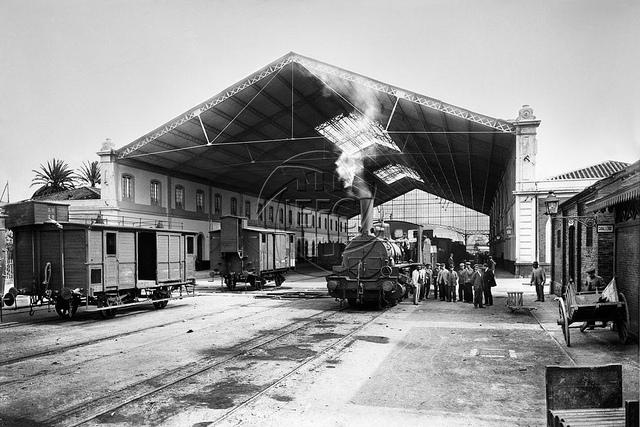Is the picture black and white?
Be succinct. Yes. Is this a modern picture?
Keep it brief. No. Does the picture have any enhancements?
Concise answer only. No. 